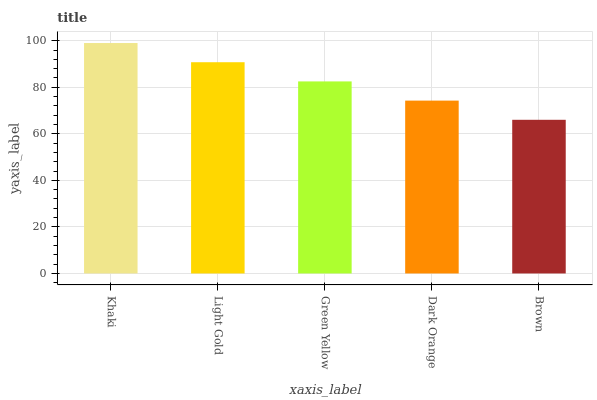Is Brown the minimum?
Answer yes or no. Yes. Is Khaki the maximum?
Answer yes or no. Yes. Is Light Gold the minimum?
Answer yes or no. No. Is Light Gold the maximum?
Answer yes or no. No. Is Khaki greater than Light Gold?
Answer yes or no. Yes. Is Light Gold less than Khaki?
Answer yes or no. Yes. Is Light Gold greater than Khaki?
Answer yes or no. No. Is Khaki less than Light Gold?
Answer yes or no. No. Is Green Yellow the high median?
Answer yes or no. Yes. Is Green Yellow the low median?
Answer yes or no. Yes. Is Light Gold the high median?
Answer yes or no. No. Is Light Gold the low median?
Answer yes or no. No. 